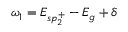<formula> <loc_0><loc_0><loc_500><loc_500>\omega _ { 1 } = E _ { s p _ { 2 } ^ { + } } - E _ { g } + \delta</formula> 